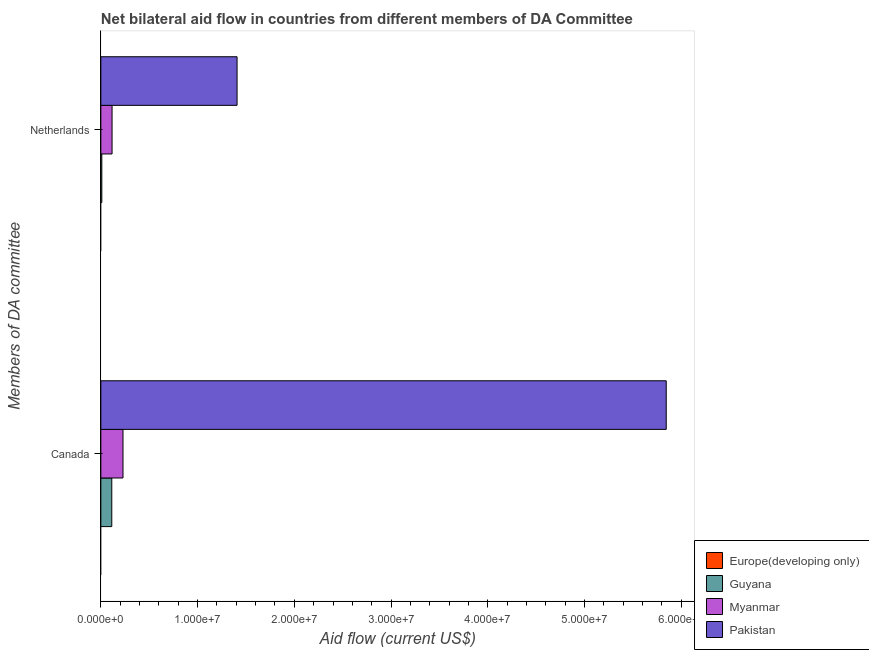How many groups of bars are there?
Provide a short and direct response. 2. Are the number of bars on each tick of the Y-axis equal?
Ensure brevity in your answer.  Yes. How many bars are there on the 2nd tick from the top?
Offer a very short reply. 3. How many bars are there on the 2nd tick from the bottom?
Keep it short and to the point. 3. What is the label of the 1st group of bars from the top?
Provide a succinct answer. Netherlands. What is the amount of aid given by canada in Pakistan?
Give a very brief answer. 5.84e+07. Across all countries, what is the maximum amount of aid given by canada?
Offer a very short reply. 5.84e+07. Across all countries, what is the minimum amount of aid given by netherlands?
Your answer should be compact. 0. What is the total amount of aid given by canada in the graph?
Your answer should be very brief. 6.19e+07. What is the difference between the amount of aid given by netherlands in Guyana and that in Pakistan?
Offer a terse response. -1.40e+07. What is the difference between the amount of aid given by canada in Myanmar and the amount of aid given by netherlands in Pakistan?
Ensure brevity in your answer.  -1.18e+07. What is the average amount of aid given by netherlands per country?
Your answer should be very brief. 3.84e+06. What is the difference between the amount of aid given by canada and amount of aid given by netherlands in Guyana?
Give a very brief answer. 1.03e+06. What is the ratio of the amount of aid given by netherlands in Guyana to that in Pakistan?
Provide a short and direct response. 0.01. Is the amount of aid given by canada in Guyana less than that in Myanmar?
Provide a succinct answer. Yes. How many bars are there?
Provide a succinct answer. 6. How many countries are there in the graph?
Give a very brief answer. 4. Are the values on the major ticks of X-axis written in scientific E-notation?
Ensure brevity in your answer.  Yes. How many legend labels are there?
Make the answer very short. 4. What is the title of the graph?
Provide a succinct answer. Net bilateral aid flow in countries from different members of DA Committee. What is the label or title of the Y-axis?
Your answer should be compact. Members of DA committee. What is the Aid flow (current US$) of Europe(developing only) in Canada?
Provide a succinct answer. 0. What is the Aid flow (current US$) in Guyana in Canada?
Offer a very short reply. 1.13e+06. What is the Aid flow (current US$) in Myanmar in Canada?
Ensure brevity in your answer.  2.29e+06. What is the Aid flow (current US$) in Pakistan in Canada?
Give a very brief answer. 5.84e+07. What is the Aid flow (current US$) of Myanmar in Netherlands?
Keep it short and to the point. 1.16e+06. What is the Aid flow (current US$) in Pakistan in Netherlands?
Your response must be concise. 1.41e+07. Across all Members of DA committee, what is the maximum Aid flow (current US$) in Guyana?
Provide a short and direct response. 1.13e+06. Across all Members of DA committee, what is the maximum Aid flow (current US$) of Myanmar?
Make the answer very short. 2.29e+06. Across all Members of DA committee, what is the maximum Aid flow (current US$) in Pakistan?
Ensure brevity in your answer.  5.84e+07. Across all Members of DA committee, what is the minimum Aid flow (current US$) in Guyana?
Provide a succinct answer. 1.00e+05. Across all Members of DA committee, what is the minimum Aid flow (current US$) of Myanmar?
Your response must be concise. 1.16e+06. Across all Members of DA committee, what is the minimum Aid flow (current US$) of Pakistan?
Make the answer very short. 1.41e+07. What is the total Aid flow (current US$) in Europe(developing only) in the graph?
Offer a very short reply. 0. What is the total Aid flow (current US$) of Guyana in the graph?
Your answer should be very brief. 1.23e+06. What is the total Aid flow (current US$) of Myanmar in the graph?
Your response must be concise. 3.45e+06. What is the total Aid flow (current US$) of Pakistan in the graph?
Your answer should be very brief. 7.25e+07. What is the difference between the Aid flow (current US$) of Guyana in Canada and that in Netherlands?
Offer a terse response. 1.03e+06. What is the difference between the Aid flow (current US$) in Myanmar in Canada and that in Netherlands?
Keep it short and to the point. 1.13e+06. What is the difference between the Aid flow (current US$) in Pakistan in Canada and that in Netherlands?
Your answer should be very brief. 4.44e+07. What is the difference between the Aid flow (current US$) in Guyana in Canada and the Aid flow (current US$) in Myanmar in Netherlands?
Your answer should be compact. -3.00e+04. What is the difference between the Aid flow (current US$) of Guyana in Canada and the Aid flow (current US$) of Pakistan in Netherlands?
Give a very brief answer. -1.30e+07. What is the difference between the Aid flow (current US$) of Myanmar in Canada and the Aid flow (current US$) of Pakistan in Netherlands?
Make the answer very short. -1.18e+07. What is the average Aid flow (current US$) of Guyana per Members of DA committee?
Offer a very short reply. 6.15e+05. What is the average Aid flow (current US$) of Myanmar per Members of DA committee?
Offer a terse response. 1.72e+06. What is the average Aid flow (current US$) in Pakistan per Members of DA committee?
Offer a terse response. 3.63e+07. What is the difference between the Aid flow (current US$) of Guyana and Aid flow (current US$) of Myanmar in Canada?
Your answer should be compact. -1.16e+06. What is the difference between the Aid flow (current US$) of Guyana and Aid flow (current US$) of Pakistan in Canada?
Your answer should be compact. -5.73e+07. What is the difference between the Aid flow (current US$) in Myanmar and Aid flow (current US$) in Pakistan in Canada?
Give a very brief answer. -5.62e+07. What is the difference between the Aid flow (current US$) of Guyana and Aid flow (current US$) of Myanmar in Netherlands?
Provide a short and direct response. -1.06e+06. What is the difference between the Aid flow (current US$) in Guyana and Aid flow (current US$) in Pakistan in Netherlands?
Your answer should be compact. -1.40e+07. What is the difference between the Aid flow (current US$) of Myanmar and Aid flow (current US$) of Pakistan in Netherlands?
Provide a succinct answer. -1.29e+07. What is the ratio of the Aid flow (current US$) of Guyana in Canada to that in Netherlands?
Provide a succinct answer. 11.3. What is the ratio of the Aid flow (current US$) of Myanmar in Canada to that in Netherlands?
Provide a short and direct response. 1.97. What is the ratio of the Aid flow (current US$) in Pakistan in Canada to that in Netherlands?
Make the answer very short. 4.15. What is the difference between the highest and the second highest Aid flow (current US$) in Guyana?
Your response must be concise. 1.03e+06. What is the difference between the highest and the second highest Aid flow (current US$) in Myanmar?
Ensure brevity in your answer.  1.13e+06. What is the difference between the highest and the second highest Aid flow (current US$) in Pakistan?
Keep it short and to the point. 4.44e+07. What is the difference between the highest and the lowest Aid flow (current US$) of Guyana?
Give a very brief answer. 1.03e+06. What is the difference between the highest and the lowest Aid flow (current US$) in Myanmar?
Give a very brief answer. 1.13e+06. What is the difference between the highest and the lowest Aid flow (current US$) in Pakistan?
Ensure brevity in your answer.  4.44e+07. 